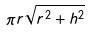Convert formula to latex. <formula><loc_0><loc_0><loc_500><loc_500>\pi r \sqrt { r ^ { 2 } + h ^ { 2 } }</formula> 